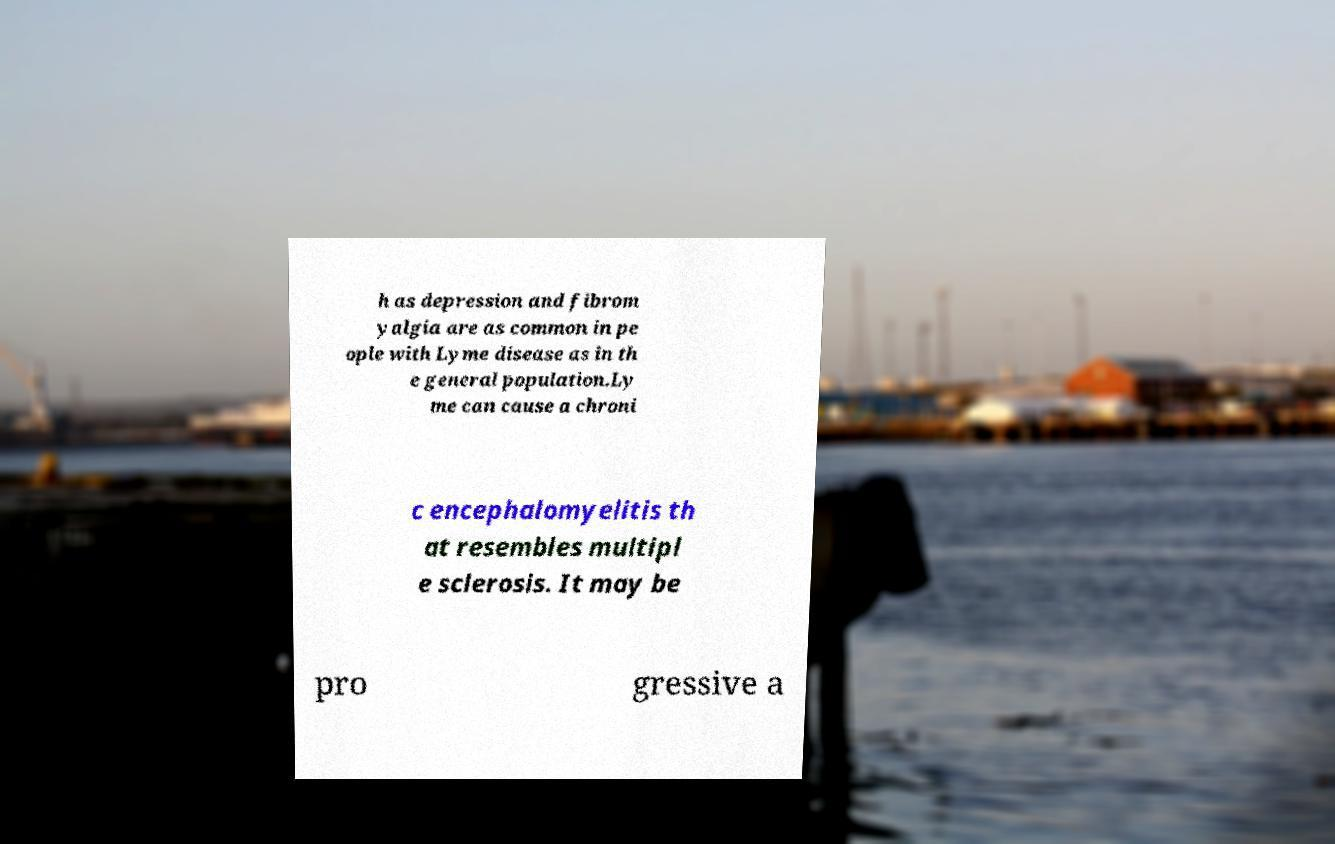Please read and relay the text visible in this image. What does it say? h as depression and fibrom yalgia are as common in pe ople with Lyme disease as in th e general population.Ly me can cause a chroni c encephalomyelitis th at resembles multipl e sclerosis. It may be pro gressive a 